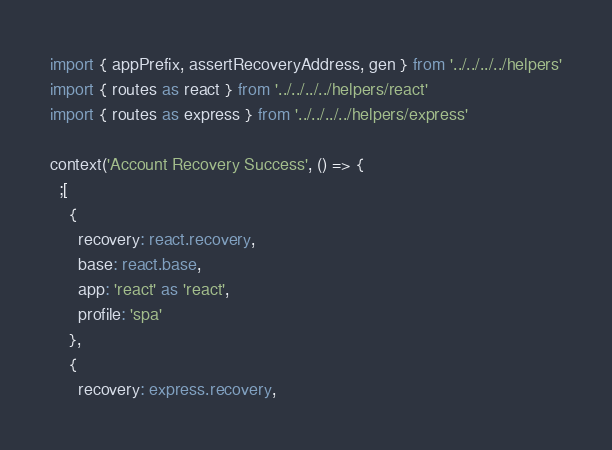<code> <loc_0><loc_0><loc_500><loc_500><_TypeScript_>import { appPrefix, assertRecoveryAddress, gen } from '../../../../helpers'
import { routes as react } from '../../../../helpers/react'
import { routes as express } from '../../../../helpers/express'

context('Account Recovery Success', () => {
  ;[
    {
      recovery: react.recovery,
      base: react.base,
      app: 'react' as 'react',
      profile: 'spa'
    },
    {
      recovery: express.recovery,</code> 